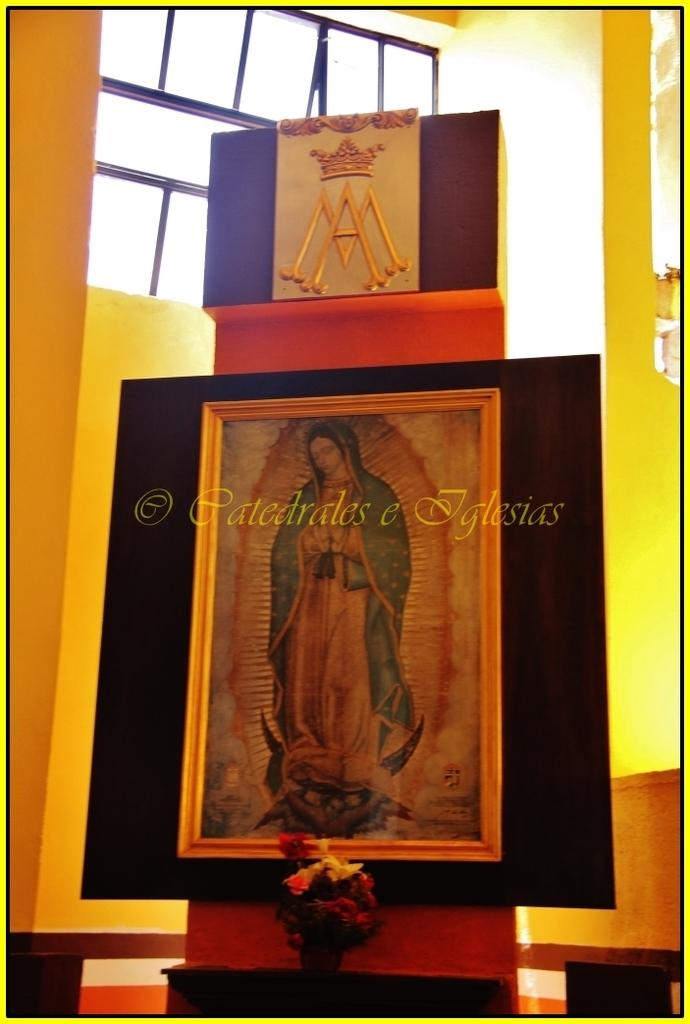<image>
Summarize the visual content of the image. A portrait of a holy figure with the watermark Catedrales e Iglesias. 